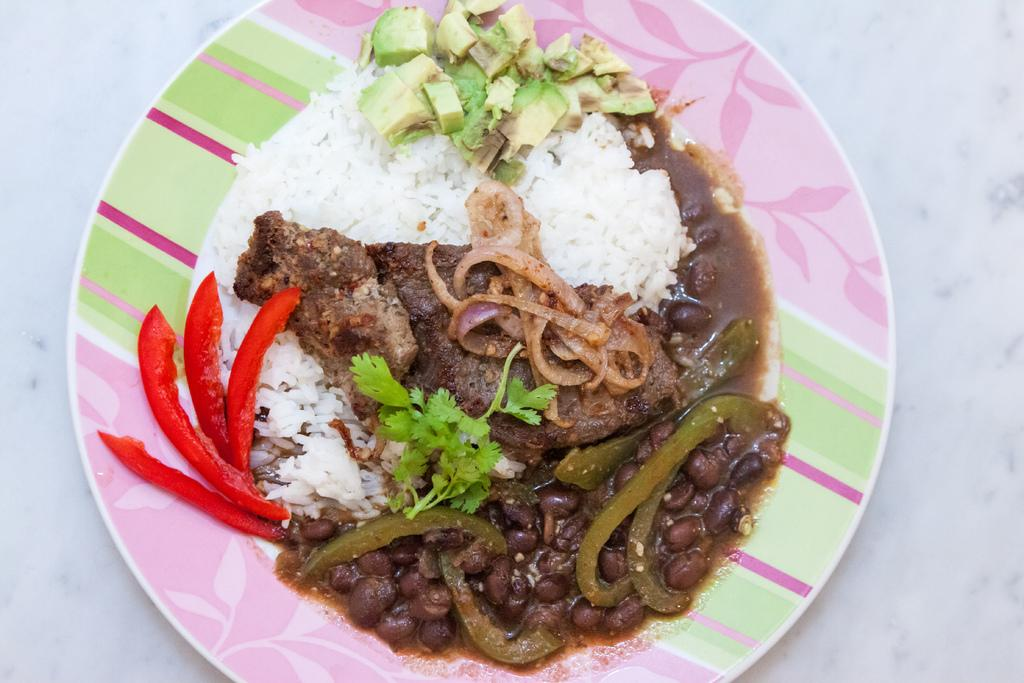What is placed on the plate in the image? There are eatables placed in a plate in the image. What type of flag is visible in the image? There is no flag present in the image; it only features a plate with eatables. Can you see a snail crawling on the plate in the image? There is no snail visible on the plate in the image. 